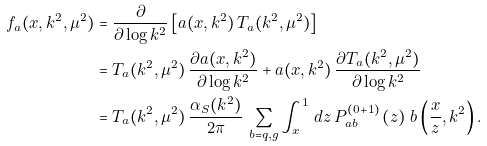Convert formula to latex. <formula><loc_0><loc_0><loc_500><loc_500>f _ { a } ( x , k ^ { 2 } , \mu ^ { 2 } ) & = \frac { \partial } { \partial \log k ^ { 2 } } \left [ a ( x , k ^ { 2 } ) \, T _ { a } ( k ^ { 2 } , \mu ^ { 2 } ) \right ] \\ & = T _ { a } ( k ^ { 2 } , \mu ^ { 2 } ) \, \frac { \partial a ( x , k ^ { 2 } ) } { \partial \log k ^ { 2 } } + a ( x , k ^ { 2 } ) \, \frac { \partial T _ { a } ( k ^ { 2 } , \mu ^ { 2 } ) } { \partial \log k ^ { 2 } } \\ & = T _ { a } ( k ^ { 2 } , \mu ^ { 2 } ) \, \frac { \alpha _ { S } ( k ^ { 2 } ) } { 2 \pi } \, \sum _ { b = q , g } \int _ { x } ^ { 1 } \, d z \, P _ { a b } ^ { ( 0 + 1 ) } \left ( z \right ) \, b \left ( \frac { x } { z } , k ^ { 2 } \right ) .</formula> 